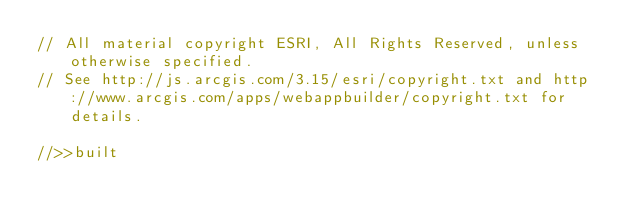Convert code to text. <code><loc_0><loc_0><loc_500><loc_500><_JavaScript_>// All material copyright ESRI, All Rights Reserved, unless otherwise specified.
// See http://js.arcgis.com/3.15/esri/copyright.txt and http://www.arcgis.com/apps/webappbuilder/copyright.txt for details.
//>>built</code> 